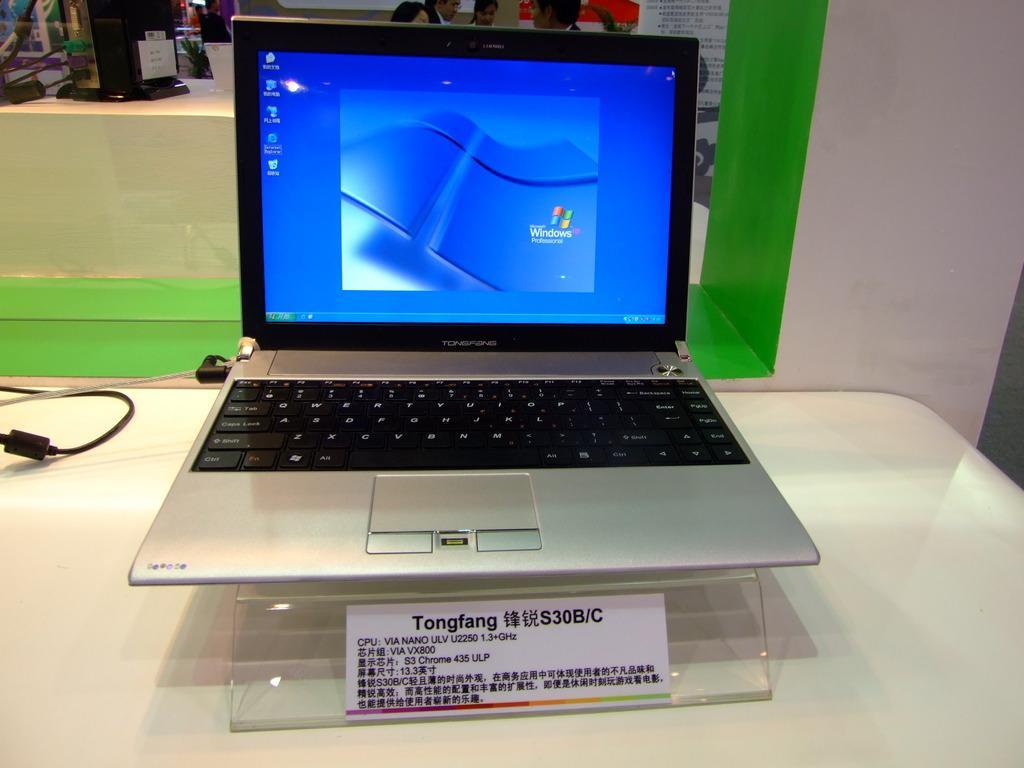Describe this image in one or two sentences. In this image there is a laptop placed on the table. On back side we can see some people. 